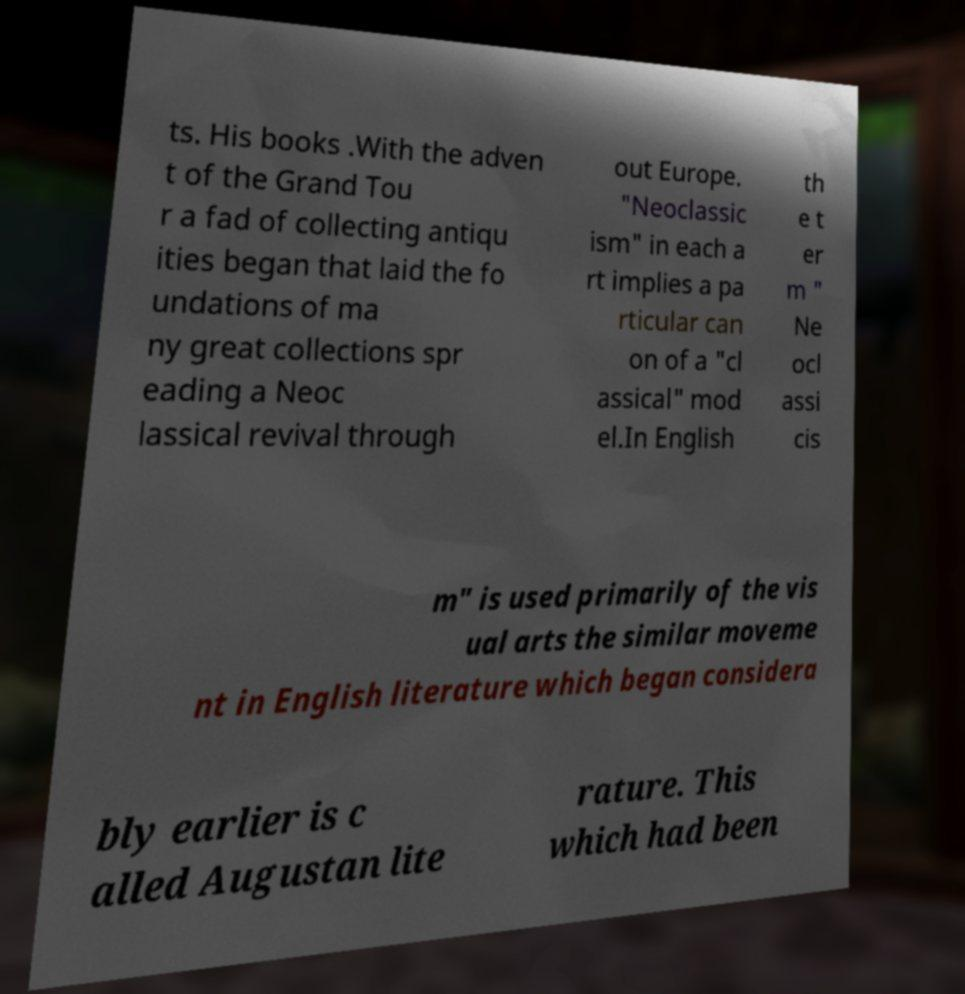Please identify and transcribe the text found in this image. ts. His books .With the adven t of the Grand Tou r a fad of collecting antiqu ities began that laid the fo undations of ma ny great collections spr eading a Neoc lassical revival through out Europe. "Neoclassic ism" in each a rt implies a pa rticular can on of a "cl assical" mod el.In English th e t er m " Ne ocl assi cis m" is used primarily of the vis ual arts the similar moveme nt in English literature which began considera bly earlier is c alled Augustan lite rature. This which had been 